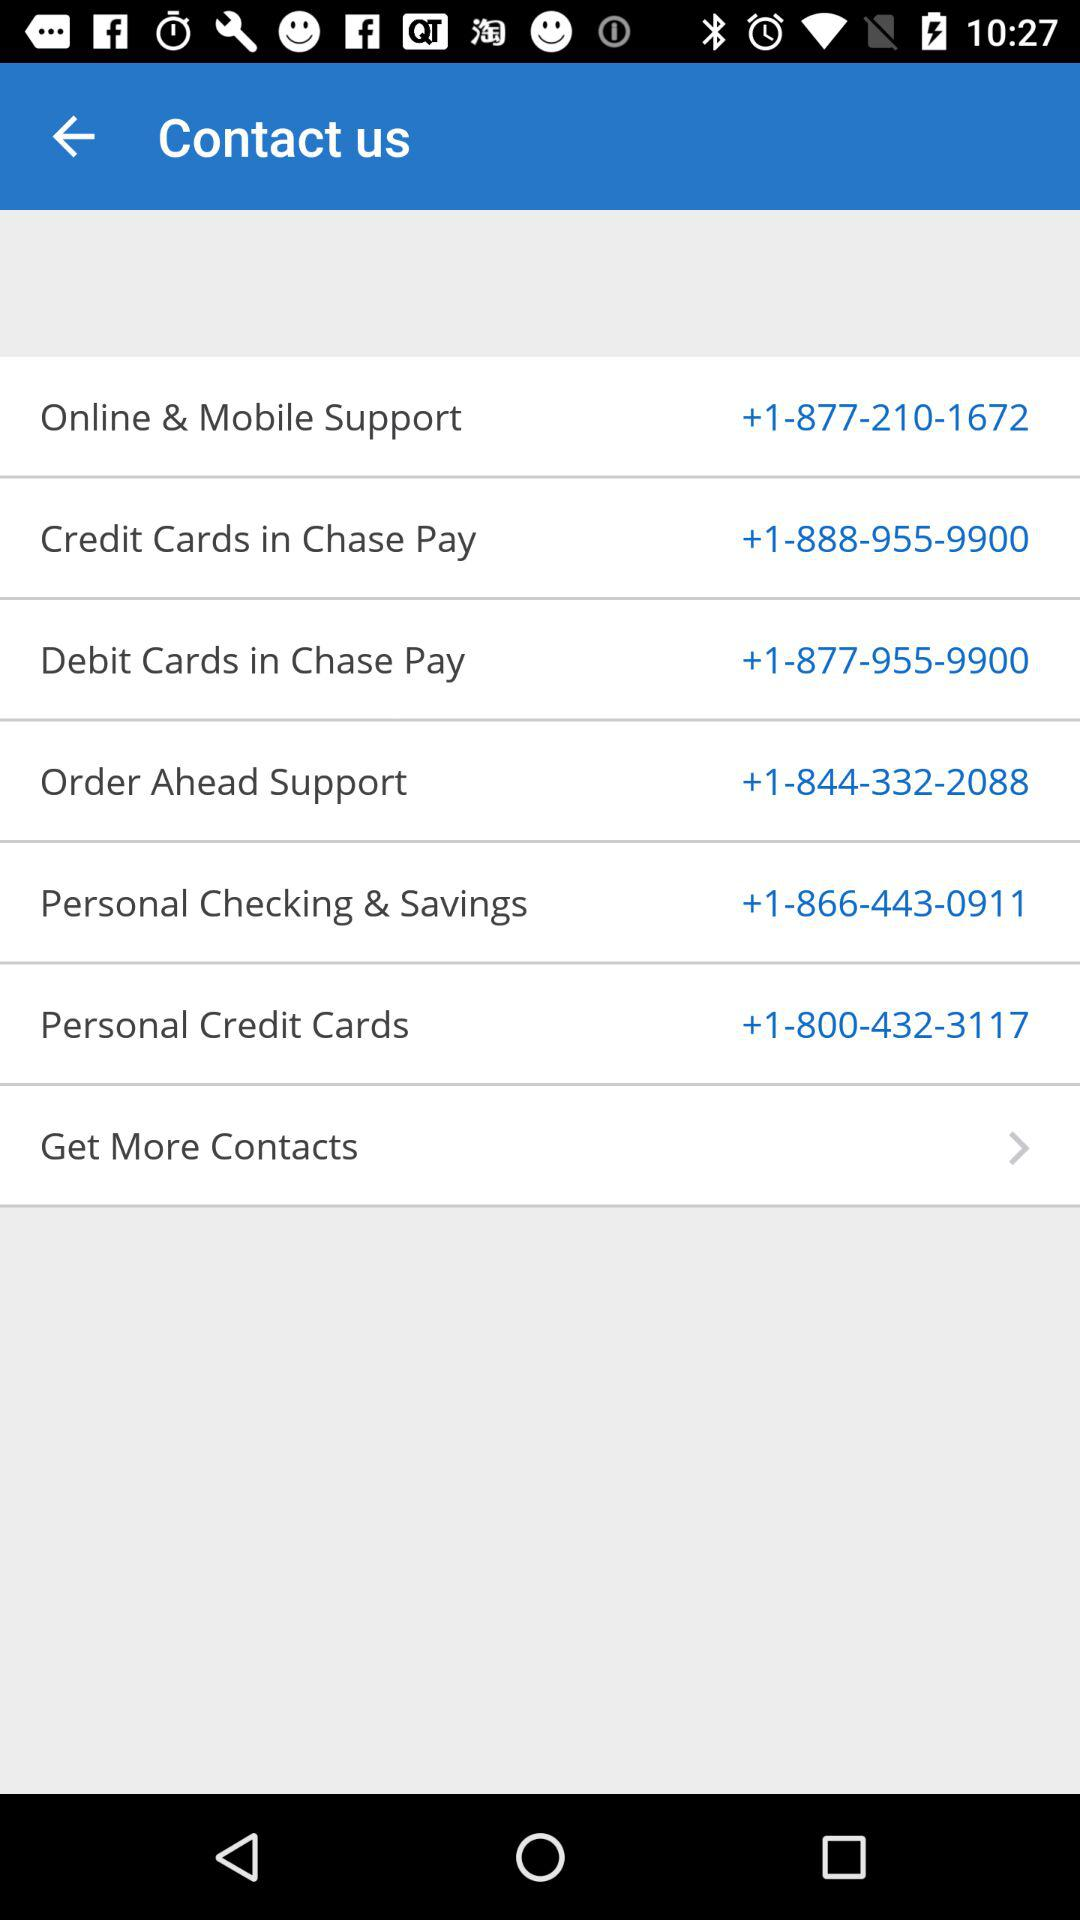What is the contact number of "Credit Cards in Chase Pay"? The contact number is +1-888-955-9900. 